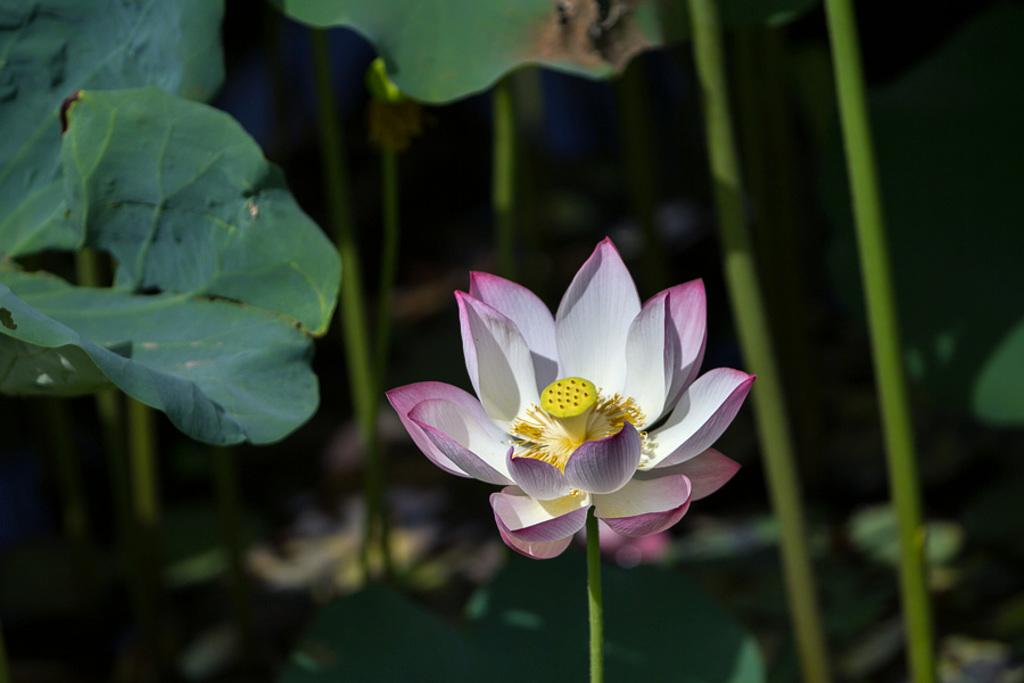What is the main subject of the image? There is a flower in the middle of the image. What can be seen in the background of the image? There are plants in the background of the image. What type of drum is being played by the team in the image? There is no team or drum present in the image; it only features a flower and plants in the background. 